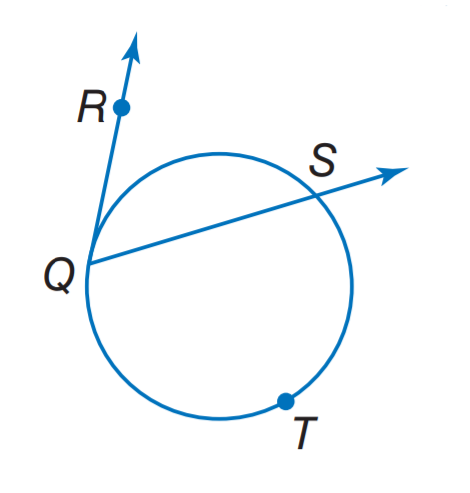Question: Find m \widehat R Q S if m \widehat Q T S = 238.
Choices:
A. 29
B. 61
C. 83
D. 119
Answer with the letter. Answer: B 